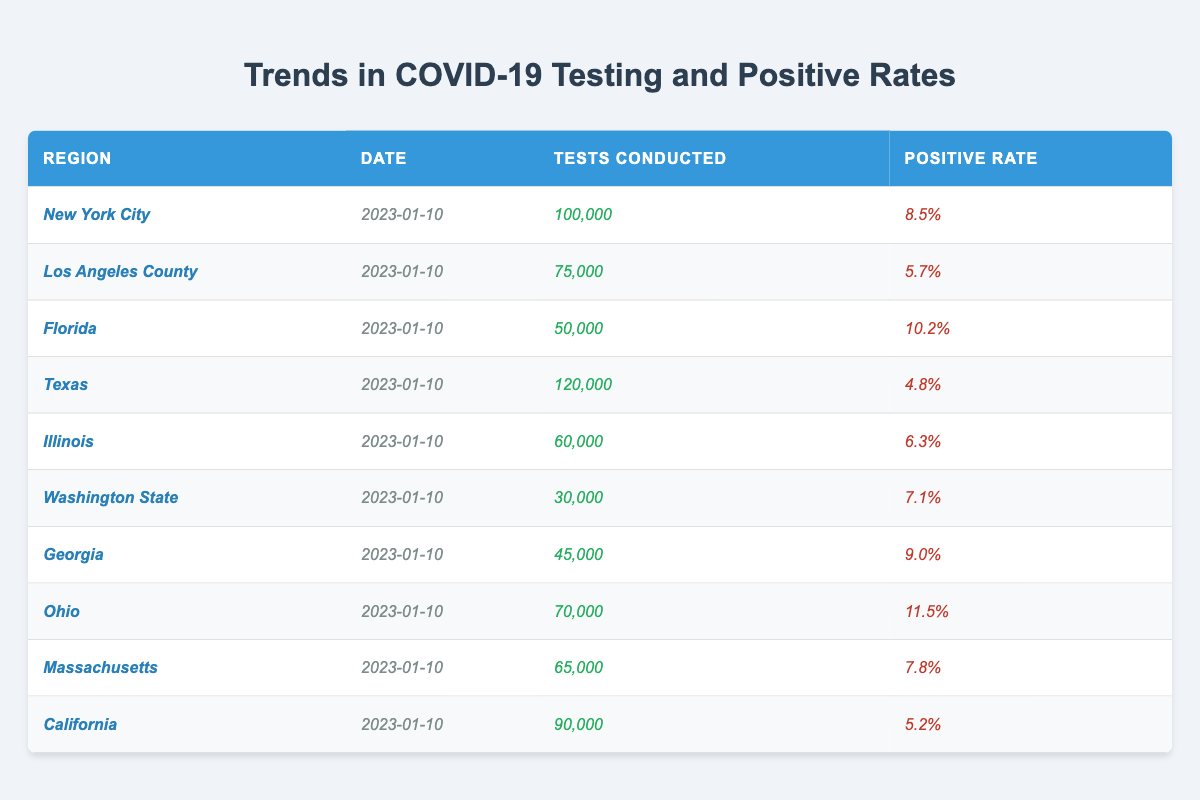What is the positive rate for Florida? The table shows the row for Florida, which indicates a positive rate of 10.2%.
Answer: 10.2% Which region conducted the highest number of tests on January 10, 2023? By examining the "Tests Conducted" column, Texas stands out with 120,000 tests, the highest among all regions.
Answer: Texas What is the average positive rate of all regions listed? To find the average positive rate, add the rates: (8.5% + 5.7% + 10.2% + 4.8% + 6.3% + 7.1% + 9.0% + 11.5% + 7.8% + 5.2%) = 75.1%. Then divide by the number of regions (10): 75.1% / 10 = 7.51%.
Answer: 7.51% Did any region have a positive rate below 5%? Looking through the "Positive Rate" column, the lowest rate noted is 4.8% for Texas, which does indicate a positive rate under 5%.
Answer: Yes Which region had the lowest positive rate? Reviewing the "Positive Rate" column, Texas with a positive rate of 4.8% is the lowest rate reported in the table.
Answer: Texas How many tests were conducted in total across all regions? To calculate the total, sum all the tests conducted: 100,000 + 75,000 + 50,000 + 120,000 + 60,000 + 30,000 + 45,000 + 70,000 + 65,000 + 90,000 =  840,000 tests.
Answer: 840,000 Which two regions have the closest positive rates? By comparing positive rates, Massachusetts (7.8%) and Washington State (7.1%) have rates closest to each other, with a difference of 0.7%.
Answer: Massachusetts and Washington State Is the positive rate for New York City higher than that for California? Comparing the positive rates, New York City has 8.5% while California has 5.2%, indicating that New York City's rate is indeed higher.
Answer: Yes What is the difference in positive rates between Ohio and Texas? Ohio has a positive rate of 11.5% and Texas has 4.8%. To find the difference, calculate 11.5% - 4.8% = 6.7%.
Answer: 6.7% On which date were the statistics recorded? The date is indicated directly in all rows of the table, showing that the statistics were recorded on January 10, 2023.
Answer: January 10, 2023 